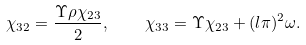<formula> <loc_0><loc_0><loc_500><loc_500>\chi _ { 3 2 } = \frac { \Upsilon \rho \chi _ { 2 3 } } { 2 } , \quad \chi _ { 3 3 } = \Upsilon \chi _ { 2 3 } + ( l \pi ) ^ { 2 } \omega .</formula> 